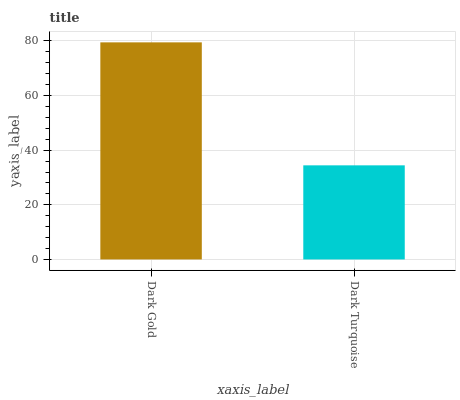Is Dark Turquoise the maximum?
Answer yes or no. No. Is Dark Gold greater than Dark Turquoise?
Answer yes or no. Yes. Is Dark Turquoise less than Dark Gold?
Answer yes or no. Yes. Is Dark Turquoise greater than Dark Gold?
Answer yes or no. No. Is Dark Gold less than Dark Turquoise?
Answer yes or no. No. Is Dark Gold the high median?
Answer yes or no. Yes. Is Dark Turquoise the low median?
Answer yes or no. Yes. Is Dark Turquoise the high median?
Answer yes or no. No. Is Dark Gold the low median?
Answer yes or no. No. 